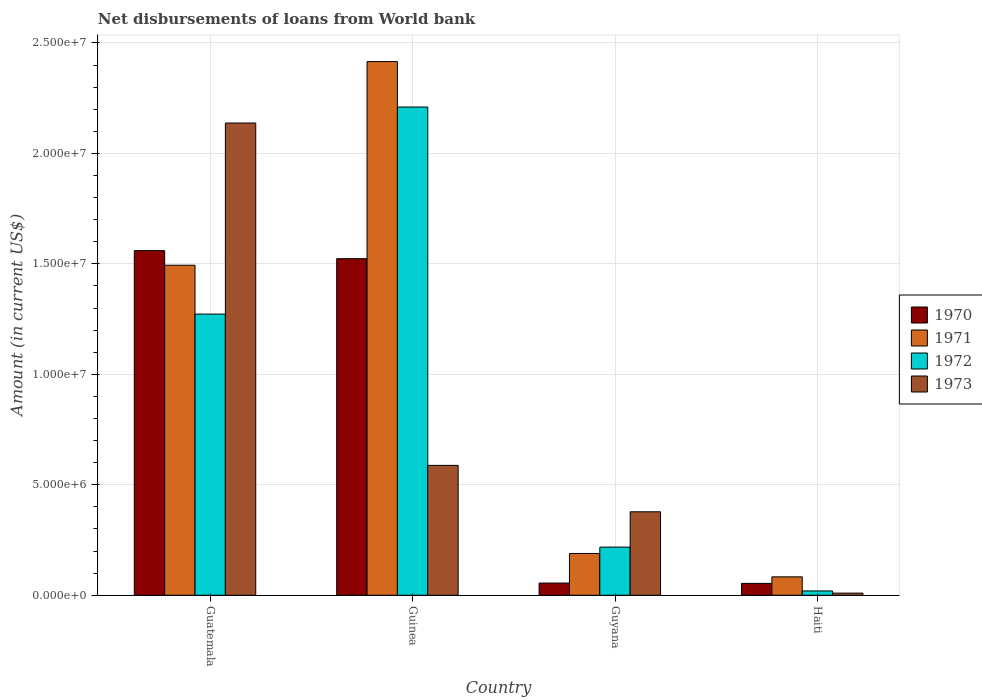How many different coloured bars are there?
Your answer should be compact. 4. Are the number of bars per tick equal to the number of legend labels?
Keep it short and to the point. Yes. Are the number of bars on each tick of the X-axis equal?
Provide a short and direct response. Yes. What is the label of the 3rd group of bars from the left?
Your answer should be compact. Guyana. What is the amount of loan disbursed from World Bank in 1970 in Haiti?
Give a very brief answer. 5.38e+05. Across all countries, what is the maximum amount of loan disbursed from World Bank in 1972?
Provide a succinct answer. 2.21e+07. Across all countries, what is the minimum amount of loan disbursed from World Bank in 1970?
Keep it short and to the point. 5.38e+05. In which country was the amount of loan disbursed from World Bank in 1973 maximum?
Your answer should be very brief. Guatemala. In which country was the amount of loan disbursed from World Bank in 1971 minimum?
Provide a succinct answer. Haiti. What is the total amount of loan disbursed from World Bank in 1970 in the graph?
Provide a succinct answer. 3.19e+07. What is the difference between the amount of loan disbursed from World Bank in 1971 in Guatemala and that in Guinea?
Provide a succinct answer. -9.22e+06. What is the difference between the amount of loan disbursed from World Bank in 1973 in Guatemala and the amount of loan disbursed from World Bank in 1971 in Haiti?
Keep it short and to the point. 2.05e+07. What is the average amount of loan disbursed from World Bank in 1973 per country?
Provide a succinct answer. 7.78e+06. What is the difference between the amount of loan disbursed from World Bank of/in 1971 and amount of loan disbursed from World Bank of/in 1973 in Guatemala?
Provide a short and direct response. -6.44e+06. What is the ratio of the amount of loan disbursed from World Bank in 1972 in Guyana to that in Haiti?
Your response must be concise. 11.12. Is the amount of loan disbursed from World Bank in 1973 in Guatemala less than that in Guyana?
Ensure brevity in your answer.  No. Is the difference between the amount of loan disbursed from World Bank in 1971 in Guatemala and Guinea greater than the difference between the amount of loan disbursed from World Bank in 1973 in Guatemala and Guinea?
Make the answer very short. No. What is the difference between the highest and the second highest amount of loan disbursed from World Bank in 1970?
Your answer should be very brief. 1.50e+07. What is the difference between the highest and the lowest amount of loan disbursed from World Bank in 1972?
Give a very brief answer. 2.19e+07. In how many countries, is the amount of loan disbursed from World Bank in 1972 greater than the average amount of loan disbursed from World Bank in 1972 taken over all countries?
Give a very brief answer. 2. Is the sum of the amount of loan disbursed from World Bank in 1973 in Guinea and Guyana greater than the maximum amount of loan disbursed from World Bank in 1971 across all countries?
Make the answer very short. No. Is it the case that in every country, the sum of the amount of loan disbursed from World Bank in 1971 and amount of loan disbursed from World Bank in 1972 is greater than the amount of loan disbursed from World Bank in 1970?
Ensure brevity in your answer.  Yes. How many bars are there?
Provide a short and direct response. 16. Are all the bars in the graph horizontal?
Your answer should be compact. No. How many countries are there in the graph?
Give a very brief answer. 4. Are the values on the major ticks of Y-axis written in scientific E-notation?
Ensure brevity in your answer.  Yes. Does the graph contain any zero values?
Keep it short and to the point. No. Where does the legend appear in the graph?
Offer a very short reply. Center right. How are the legend labels stacked?
Give a very brief answer. Vertical. What is the title of the graph?
Keep it short and to the point. Net disbursements of loans from World bank. What is the label or title of the X-axis?
Offer a terse response. Country. What is the Amount (in current US$) of 1970 in Guatemala?
Provide a succinct answer. 1.56e+07. What is the Amount (in current US$) of 1971 in Guatemala?
Make the answer very short. 1.49e+07. What is the Amount (in current US$) of 1972 in Guatemala?
Your response must be concise. 1.27e+07. What is the Amount (in current US$) of 1973 in Guatemala?
Offer a very short reply. 2.14e+07. What is the Amount (in current US$) of 1970 in Guinea?
Give a very brief answer. 1.52e+07. What is the Amount (in current US$) in 1971 in Guinea?
Make the answer very short. 2.42e+07. What is the Amount (in current US$) of 1972 in Guinea?
Your answer should be very brief. 2.21e+07. What is the Amount (in current US$) of 1973 in Guinea?
Offer a very short reply. 5.88e+06. What is the Amount (in current US$) of 1970 in Guyana?
Your response must be concise. 5.53e+05. What is the Amount (in current US$) of 1971 in Guyana?
Offer a very short reply. 1.89e+06. What is the Amount (in current US$) of 1972 in Guyana?
Offer a terse response. 2.18e+06. What is the Amount (in current US$) of 1973 in Guyana?
Offer a terse response. 3.78e+06. What is the Amount (in current US$) in 1970 in Haiti?
Provide a succinct answer. 5.38e+05. What is the Amount (in current US$) of 1971 in Haiti?
Offer a terse response. 8.34e+05. What is the Amount (in current US$) in 1972 in Haiti?
Your response must be concise. 1.96e+05. What is the Amount (in current US$) of 1973 in Haiti?
Provide a succinct answer. 9.80e+04. Across all countries, what is the maximum Amount (in current US$) in 1970?
Provide a short and direct response. 1.56e+07. Across all countries, what is the maximum Amount (in current US$) in 1971?
Your answer should be very brief. 2.42e+07. Across all countries, what is the maximum Amount (in current US$) of 1972?
Provide a short and direct response. 2.21e+07. Across all countries, what is the maximum Amount (in current US$) of 1973?
Your answer should be very brief. 2.14e+07. Across all countries, what is the minimum Amount (in current US$) in 1970?
Offer a very short reply. 5.38e+05. Across all countries, what is the minimum Amount (in current US$) of 1971?
Your response must be concise. 8.34e+05. Across all countries, what is the minimum Amount (in current US$) of 1972?
Offer a very short reply. 1.96e+05. Across all countries, what is the minimum Amount (in current US$) in 1973?
Offer a very short reply. 9.80e+04. What is the total Amount (in current US$) in 1970 in the graph?
Keep it short and to the point. 3.19e+07. What is the total Amount (in current US$) in 1971 in the graph?
Give a very brief answer. 4.18e+07. What is the total Amount (in current US$) in 1972 in the graph?
Ensure brevity in your answer.  3.72e+07. What is the total Amount (in current US$) of 1973 in the graph?
Your response must be concise. 3.11e+07. What is the difference between the Amount (in current US$) in 1970 in Guatemala and that in Guinea?
Your answer should be very brief. 3.64e+05. What is the difference between the Amount (in current US$) of 1971 in Guatemala and that in Guinea?
Give a very brief answer. -9.22e+06. What is the difference between the Amount (in current US$) in 1972 in Guatemala and that in Guinea?
Provide a short and direct response. -9.37e+06. What is the difference between the Amount (in current US$) of 1973 in Guatemala and that in Guinea?
Offer a terse response. 1.55e+07. What is the difference between the Amount (in current US$) of 1970 in Guatemala and that in Guyana?
Offer a very short reply. 1.50e+07. What is the difference between the Amount (in current US$) in 1971 in Guatemala and that in Guyana?
Give a very brief answer. 1.30e+07. What is the difference between the Amount (in current US$) in 1972 in Guatemala and that in Guyana?
Make the answer very short. 1.05e+07. What is the difference between the Amount (in current US$) in 1973 in Guatemala and that in Guyana?
Your answer should be compact. 1.76e+07. What is the difference between the Amount (in current US$) of 1970 in Guatemala and that in Haiti?
Ensure brevity in your answer.  1.51e+07. What is the difference between the Amount (in current US$) of 1971 in Guatemala and that in Haiti?
Your answer should be compact. 1.41e+07. What is the difference between the Amount (in current US$) of 1972 in Guatemala and that in Haiti?
Give a very brief answer. 1.25e+07. What is the difference between the Amount (in current US$) of 1973 in Guatemala and that in Haiti?
Offer a terse response. 2.13e+07. What is the difference between the Amount (in current US$) of 1970 in Guinea and that in Guyana?
Ensure brevity in your answer.  1.47e+07. What is the difference between the Amount (in current US$) in 1971 in Guinea and that in Guyana?
Your response must be concise. 2.23e+07. What is the difference between the Amount (in current US$) of 1972 in Guinea and that in Guyana?
Your answer should be compact. 1.99e+07. What is the difference between the Amount (in current US$) of 1973 in Guinea and that in Guyana?
Give a very brief answer. 2.10e+06. What is the difference between the Amount (in current US$) in 1970 in Guinea and that in Haiti?
Your answer should be compact. 1.47e+07. What is the difference between the Amount (in current US$) in 1971 in Guinea and that in Haiti?
Ensure brevity in your answer.  2.33e+07. What is the difference between the Amount (in current US$) in 1972 in Guinea and that in Haiti?
Offer a very short reply. 2.19e+07. What is the difference between the Amount (in current US$) of 1973 in Guinea and that in Haiti?
Offer a terse response. 5.78e+06. What is the difference between the Amount (in current US$) in 1970 in Guyana and that in Haiti?
Your answer should be compact. 1.50e+04. What is the difference between the Amount (in current US$) in 1971 in Guyana and that in Haiti?
Provide a succinct answer. 1.06e+06. What is the difference between the Amount (in current US$) of 1972 in Guyana and that in Haiti?
Provide a succinct answer. 1.98e+06. What is the difference between the Amount (in current US$) of 1973 in Guyana and that in Haiti?
Your answer should be compact. 3.68e+06. What is the difference between the Amount (in current US$) in 1970 in Guatemala and the Amount (in current US$) in 1971 in Guinea?
Keep it short and to the point. -8.56e+06. What is the difference between the Amount (in current US$) of 1970 in Guatemala and the Amount (in current US$) of 1972 in Guinea?
Make the answer very short. -6.50e+06. What is the difference between the Amount (in current US$) in 1970 in Guatemala and the Amount (in current US$) in 1973 in Guinea?
Your response must be concise. 9.72e+06. What is the difference between the Amount (in current US$) of 1971 in Guatemala and the Amount (in current US$) of 1972 in Guinea?
Ensure brevity in your answer.  -7.16e+06. What is the difference between the Amount (in current US$) in 1971 in Guatemala and the Amount (in current US$) in 1973 in Guinea?
Offer a very short reply. 9.06e+06. What is the difference between the Amount (in current US$) of 1972 in Guatemala and the Amount (in current US$) of 1973 in Guinea?
Your response must be concise. 6.85e+06. What is the difference between the Amount (in current US$) of 1970 in Guatemala and the Amount (in current US$) of 1971 in Guyana?
Keep it short and to the point. 1.37e+07. What is the difference between the Amount (in current US$) in 1970 in Guatemala and the Amount (in current US$) in 1972 in Guyana?
Give a very brief answer. 1.34e+07. What is the difference between the Amount (in current US$) in 1970 in Guatemala and the Amount (in current US$) in 1973 in Guyana?
Offer a very short reply. 1.18e+07. What is the difference between the Amount (in current US$) in 1971 in Guatemala and the Amount (in current US$) in 1972 in Guyana?
Offer a very short reply. 1.28e+07. What is the difference between the Amount (in current US$) of 1971 in Guatemala and the Amount (in current US$) of 1973 in Guyana?
Give a very brief answer. 1.12e+07. What is the difference between the Amount (in current US$) of 1972 in Guatemala and the Amount (in current US$) of 1973 in Guyana?
Your answer should be very brief. 8.95e+06. What is the difference between the Amount (in current US$) in 1970 in Guatemala and the Amount (in current US$) in 1971 in Haiti?
Your response must be concise. 1.48e+07. What is the difference between the Amount (in current US$) of 1970 in Guatemala and the Amount (in current US$) of 1972 in Haiti?
Your answer should be compact. 1.54e+07. What is the difference between the Amount (in current US$) of 1970 in Guatemala and the Amount (in current US$) of 1973 in Haiti?
Your answer should be very brief. 1.55e+07. What is the difference between the Amount (in current US$) of 1971 in Guatemala and the Amount (in current US$) of 1972 in Haiti?
Your answer should be very brief. 1.47e+07. What is the difference between the Amount (in current US$) in 1971 in Guatemala and the Amount (in current US$) in 1973 in Haiti?
Offer a terse response. 1.48e+07. What is the difference between the Amount (in current US$) in 1972 in Guatemala and the Amount (in current US$) in 1973 in Haiti?
Keep it short and to the point. 1.26e+07. What is the difference between the Amount (in current US$) of 1970 in Guinea and the Amount (in current US$) of 1971 in Guyana?
Provide a short and direct response. 1.33e+07. What is the difference between the Amount (in current US$) of 1970 in Guinea and the Amount (in current US$) of 1972 in Guyana?
Keep it short and to the point. 1.31e+07. What is the difference between the Amount (in current US$) in 1970 in Guinea and the Amount (in current US$) in 1973 in Guyana?
Provide a succinct answer. 1.15e+07. What is the difference between the Amount (in current US$) in 1971 in Guinea and the Amount (in current US$) in 1972 in Guyana?
Provide a succinct answer. 2.20e+07. What is the difference between the Amount (in current US$) in 1971 in Guinea and the Amount (in current US$) in 1973 in Guyana?
Give a very brief answer. 2.04e+07. What is the difference between the Amount (in current US$) of 1972 in Guinea and the Amount (in current US$) of 1973 in Guyana?
Provide a short and direct response. 1.83e+07. What is the difference between the Amount (in current US$) in 1970 in Guinea and the Amount (in current US$) in 1971 in Haiti?
Give a very brief answer. 1.44e+07. What is the difference between the Amount (in current US$) of 1970 in Guinea and the Amount (in current US$) of 1972 in Haiti?
Give a very brief answer. 1.50e+07. What is the difference between the Amount (in current US$) of 1970 in Guinea and the Amount (in current US$) of 1973 in Haiti?
Your response must be concise. 1.51e+07. What is the difference between the Amount (in current US$) in 1971 in Guinea and the Amount (in current US$) in 1972 in Haiti?
Give a very brief answer. 2.40e+07. What is the difference between the Amount (in current US$) in 1971 in Guinea and the Amount (in current US$) in 1973 in Haiti?
Make the answer very short. 2.41e+07. What is the difference between the Amount (in current US$) in 1972 in Guinea and the Amount (in current US$) in 1973 in Haiti?
Provide a short and direct response. 2.20e+07. What is the difference between the Amount (in current US$) in 1970 in Guyana and the Amount (in current US$) in 1971 in Haiti?
Your answer should be compact. -2.81e+05. What is the difference between the Amount (in current US$) in 1970 in Guyana and the Amount (in current US$) in 1972 in Haiti?
Provide a succinct answer. 3.57e+05. What is the difference between the Amount (in current US$) in 1970 in Guyana and the Amount (in current US$) in 1973 in Haiti?
Your answer should be compact. 4.55e+05. What is the difference between the Amount (in current US$) of 1971 in Guyana and the Amount (in current US$) of 1972 in Haiti?
Ensure brevity in your answer.  1.70e+06. What is the difference between the Amount (in current US$) in 1971 in Guyana and the Amount (in current US$) in 1973 in Haiti?
Give a very brief answer. 1.80e+06. What is the difference between the Amount (in current US$) in 1972 in Guyana and the Amount (in current US$) in 1973 in Haiti?
Give a very brief answer. 2.08e+06. What is the average Amount (in current US$) of 1970 per country?
Make the answer very short. 7.98e+06. What is the average Amount (in current US$) in 1971 per country?
Your response must be concise. 1.05e+07. What is the average Amount (in current US$) in 1972 per country?
Provide a short and direct response. 9.30e+06. What is the average Amount (in current US$) of 1973 per country?
Ensure brevity in your answer.  7.78e+06. What is the difference between the Amount (in current US$) in 1970 and Amount (in current US$) in 1971 in Guatemala?
Provide a short and direct response. 6.60e+05. What is the difference between the Amount (in current US$) in 1970 and Amount (in current US$) in 1972 in Guatemala?
Provide a short and direct response. 2.87e+06. What is the difference between the Amount (in current US$) in 1970 and Amount (in current US$) in 1973 in Guatemala?
Offer a terse response. -5.78e+06. What is the difference between the Amount (in current US$) in 1971 and Amount (in current US$) in 1972 in Guatemala?
Your answer should be very brief. 2.21e+06. What is the difference between the Amount (in current US$) in 1971 and Amount (in current US$) in 1973 in Guatemala?
Provide a short and direct response. -6.44e+06. What is the difference between the Amount (in current US$) of 1972 and Amount (in current US$) of 1973 in Guatemala?
Give a very brief answer. -8.65e+06. What is the difference between the Amount (in current US$) of 1970 and Amount (in current US$) of 1971 in Guinea?
Your response must be concise. -8.92e+06. What is the difference between the Amount (in current US$) in 1970 and Amount (in current US$) in 1972 in Guinea?
Your answer should be very brief. -6.86e+06. What is the difference between the Amount (in current US$) in 1970 and Amount (in current US$) in 1973 in Guinea?
Your response must be concise. 9.36e+06. What is the difference between the Amount (in current US$) in 1971 and Amount (in current US$) in 1972 in Guinea?
Offer a very short reply. 2.06e+06. What is the difference between the Amount (in current US$) of 1971 and Amount (in current US$) of 1973 in Guinea?
Your response must be concise. 1.83e+07. What is the difference between the Amount (in current US$) in 1972 and Amount (in current US$) in 1973 in Guinea?
Keep it short and to the point. 1.62e+07. What is the difference between the Amount (in current US$) in 1970 and Amount (in current US$) in 1971 in Guyana?
Keep it short and to the point. -1.34e+06. What is the difference between the Amount (in current US$) in 1970 and Amount (in current US$) in 1972 in Guyana?
Provide a short and direct response. -1.63e+06. What is the difference between the Amount (in current US$) in 1970 and Amount (in current US$) in 1973 in Guyana?
Ensure brevity in your answer.  -3.23e+06. What is the difference between the Amount (in current US$) in 1971 and Amount (in current US$) in 1972 in Guyana?
Give a very brief answer. -2.87e+05. What is the difference between the Amount (in current US$) of 1971 and Amount (in current US$) of 1973 in Guyana?
Make the answer very short. -1.89e+06. What is the difference between the Amount (in current US$) of 1972 and Amount (in current US$) of 1973 in Guyana?
Provide a short and direct response. -1.60e+06. What is the difference between the Amount (in current US$) in 1970 and Amount (in current US$) in 1971 in Haiti?
Your response must be concise. -2.96e+05. What is the difference between the Amount (in current US$) in 1970 and Amount (in current US$) in 1972 in Haiti?
Make the answer very short. 3.42e+05. What is the difference between the Amount (in current US$) in 1970 and Amount (in current US$) in 1973 in Haiti?
Provide a short and direct response. 4.40e+05. What is the difference between the Amount (in current US$) of 1971 and Amount (in current US$) of 1972 in Haiti?
Your answer should be compact. 6.38e+05. What is the difference between the Amount (in current US$) of 1971 and Amount (in current US$) of 1973 in Haiti?
Ensure brevity in your answer.  7.36e+05. What is the difference between the Amount (in current US$) of 1972 and Amount (in current US$) of 1973 in Haiti?
Keep it short and to the point. 9.80e+04. What is the ratio of the Amount (in current US$) in 1970 in Guatemala to that in Guinea?
Ensure brevity in your answer.  1.02. What is the ratio of the Amount (in current US$) in 1971 in Guatemala to that in Guinea?
Give a very brief answer. 0.62. What is the ratio of the Amount (in current US$) of 1972 in Guatemala to that in Guinea?
Offer a terse response. 0.58. What is the ratio of the Amount (in current US$) of 1973 in Guatemala to that in Guinea?
Provide a short and direct response. 3.64. What is the ratio of the Amount (in current US$) in 1970 in Guatemala to that in Guyana?
Your answer should be compact. 28.21. What is the ratio of the Amount (in current US$) in 1971 in Guatemala to that in Guyana?
Ensure brevity in your answer.  7.89. What is the ratio of the Amount (in current US$) in 1972 in Guatemala to that in Guyana?
Keep it short and to the point. 5.84. What is the ratio of the Amount (in current US$) in 1973 in Guatemala to that in Guyana?
Provide a short and direct response. 5.66. What is the ratio of the Amount (in current US$) of 1970 in Guatemala to that in Haiti?
Your answer should be compact. 29. What is the ratio of the Amount (in current US$) in 1971 in Guatemala to that in Haiti?
Your answer should be very brief. 17.91. What is the ratio of the Amount (in current US$) of 1972 in Guatemala to that in Haiti?
Offer a terse response. 64.94. What is the ratio of the Amount (in current US$) of 1973 in Guatemala to that in Haiti?
Offer a very short reply. 218.13. What is the ratio of the Amount (in current US$) of 1970 in Guinea to that in Guyana?
Make the answer very short. 27.55. What is the ratio of the Amount (in current US$) in 1971 in Guinea to that in Guyana?
Give a very brief answer. 12.76. What is the ratio of the Amount (in current US$) in 1972 in Guinea to that in Guyana?
Your response must be concise. 10.14. What is the ratio of the Amount (in current US$) of 1973 in Guinea to that in Guyana?
Make the answer very short. 1.56. What is the ratio of the Amount (in current US$) of 1970 in Guinea to that in Haiti?
Your response must be concise. 28.32. What is the ratio of the Amount (in current US$) in 1971 in Guinea to that in Haiti?
Your answer should be compact. 28.97. What is the ratio of the Amount (in current US$) of 1972 in Guinea to that in Haiti?
Offer a very short reply. 112.76. What is the ratio of the Amount (in current US$) of 1973 in Guinea to that in Haiti?
Make the answer very short. 60. What is the ratio of the Amount (in current US$) of 1970 in Guyana to that in Haiti?
Your answer should be compact. 1.03. What is the ratio of the Amount (in current US$) in 1971 in Guyana to that in Haiti?
Give a very brief answer. 2.27. What is the ratio of the Amount (in current US$) in 1972 in Guyana to that in Haiti?
Ensure brevity in your answer.  11.12. What is the ratio of the Amount (in current US$) in 1973 in Guyana to that in Haiti?
Give a very brief answer. 38.56. What is the difference between the highest and the second highest Amount (in current US$) in 1970?
Offer a terse response. 3.64e+05. What is the difference between the highest and the second highest Amount (in current US$) in 1971?
Provide a succinct answer. 9.22e+06. What is the difference between the highest and the second highest Amount (in current US$) in 1972?
Give a very brief answer. 9.37e+06. What is the difference between the highest and the second highest Amount (in current US$) of 1973?
Your response must be concise. 1.55e+07. What is the difference between the highest and the lowest Amount (in current US$) in 1970?
Offer a terse response. 1.51e+07. What is the difference between the highest and the lowest Amount (in current US$) of 1971?
Keep it short and to the point. 2.33e+07. What is the difference between the highest and the lowest Amount (in current US$) of 1972?
Ensure brevity in your answer.  2.19e+07. What is the difference between the highest and the lowest Amount (in current US$) in 1973?
Provide a succinct answer. 2.13e+07. 